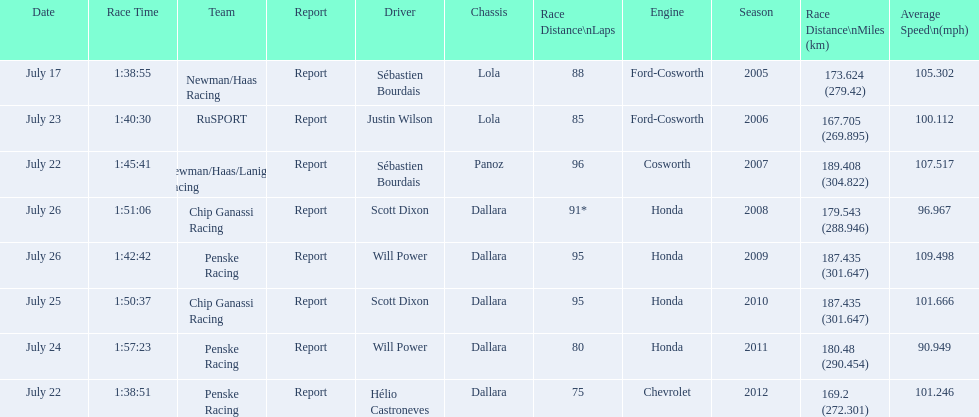Parse the full table. {'header': ['Date', 'Race Time', 'Team', 'Report', 'Driver', 'Chassis', 'Race Distance\\nLaps', 'Engine', 'Season', 'Race Distance\\nMiles (km)', 'Average Speed\\n(mph)'], 'rows': [['July 17', '1:38:55', 'Newman/Haas Racing', 'Report', 'Sébastien Bourdais', 'Lola', '88', 'Ford-Cosworth', '2005', '173.624 (279.42)', '105.302'], ['July 23', '1:40:30', 'RuSPORT', 'Report', 'Justin Wilson', 'Lola', '85', 'Ford-Cosworth', '2006', '167.705 (269.895)', '100.112'], ['July 22', '1:45:41', 'Newman/Haas/Lanigan Racing', 'Report', 'Sébastien Bourdais', 'Panoz', '96', 'Cosworth', '2007', '189.408 (304.822)', '107.517'], ['July 26', '1:51:06', 'Chip Ganassi Racing', 'Report', 'Scott Dixon', 'Dallara', '91*', 'Honda', '2008', '179.543 (288.946)', '96.967'], ['July 26', '1:42:42', 'Penske Racing', 'Report', 'Will Power', 'Dallara', '95', 'Honda', '2009', '187.435 (301.647)', '109.498'], ['July 25', '1:50:37', 'Chip Ganassi Racing', 'Report', 'Scott Dixon', 'Dallara', '95', 'Honda', '2010', '187.435 (301.647)', '101.666'], ['July 24', '1:57:23', 'Penske Racing', 'Report', 'Will Power', 'Dallara', '80', 'Honda', '2011', '180.48 (290.454)', '90.949'], ['July 22', '1:38:51', 'Penske Racing', 'Report', 'Hélio Castroneves', 'Dallara', '75', 'Chevrolet', '2012', '169.2 (272.301)', '101.246']]} Which team won the champ car world series the year before rusport? Newman/Haas Racing. 